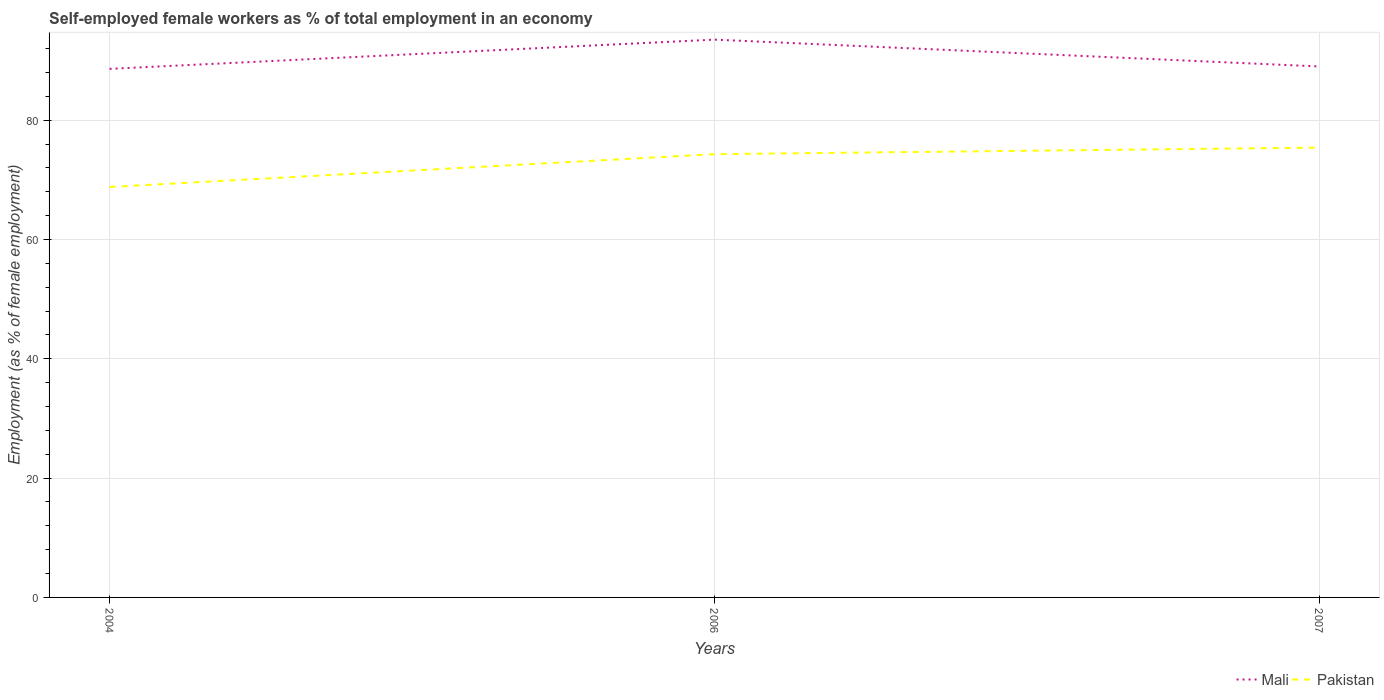How many different coloured lines are there?
Keep it short and to the point. 2. Does the line corresponding to Pakistan intersect with the line corresponding to Mali?
Make the answer very short. No. Across all years, what is the maximum percentage of self-employed female workers in Pakistan?
Your answer should be compact. 68.8. What is the total percentage of self-employed female workers in Pakistan in the graph?
Your answer should be very brief. -6.6. What is the difference between the highest and the second highest percentage of self-employed female workers in Mali?
Provide a short and direct response. 4.9. What is the difference between the highest and the lowest percentage of self-employed female workers in Pakistan?
Your answer should be compact. 2. Is the percentage of self-employed female workers in Mali strictly greater than the percentage of self-employed female workers in Pakistan over the years?
Keep it short and to the point. No. How many lines are there?
Your answer should be compact. 2. Are the values on the major ticks of Y-axis written in scientific E-notation?
Keep it short and to the point. No. Does the graph contain any zero values?
Make the answer very short. No. What is the title of the graph?
Your answer should be compact. Self-employed female workers as % of total employment in an economy. What is the label or title of the Y-axis?
Give a very brief answer. Employment (as % of female employment). What is the Employment (as % of female employment) of Mali in 2004?
Offer a terse response. 88.6. What is the Employment (as % of female employment) of Pakistan in 2004?
Your response must be concise. 68.8. What is the Employment (as % of female employment) in Mali in 2006?
Your answer should be very brief. 93.5. What is the Employment (as % of female employment) in Pakistan in 2006?
Keep it short and to the point. 74.3. What is the Employment (as % of female employment) of Mali in 2007?
Provide a short and direct response. 89. What is the Employment (as % of female employment) in Pakistan in 2007?
Your answer should be very brief. 75.4. Across all years, what is the maximum Employment (as % of female employment) in Mali?
Ensure brevity in your answer.  93.5. Across all years, what is the maximum Employment (as % of female employment) of Pakistan?
Your response must be concise. 75.4. Across all years, what is the minimum Employment (as % of female employment) in Mali?
Ensure brevity in your answer.  88.6. Across all years, what is the minimum Employment (as % of female employment) of Pakistan?
Your answer should be compact. 68.8. What is the total Employment (as % of female employment) in Mali in the graph?
Your answer should be very brief. 271.1. What is the total Employment (as % of female employment) in Pakistan in the graph?
Provide a succinct answer. 218.5. What is the difference between the Employment (as % of female employment) of Mali in 2004 and that in 2006?
Provide a short and direct response. -4.9. What is the difference between the Employment (as % of female employment) in Pakistan in 2004 and that in 2006?
Provide a short and direct response. -5.5. What is the difference between the Employment (as % of female employment) in Pakistan in 2004 and that in 2007?
Your answer should be very brief. -6.6. What is the difference between the Employment (as % of female employment) of Pakistan in 2006 and that in 2007?
Provide a succinct answer. -1.1. What is the average Employment (as % of female employment) of Mali per year?
Give a very brief answer. 90.37. What is the average Employment (as % of female employment) in Pakistan per year?
Make the answer very short. 72.83. In the year 2004, what is the difference between the Employment (as % of female employment) in Mali and Employment (as % of female employment) in Pakistan?
Offer a very short reply. 19.8. In the year 2006, what is the difference between the Employment (as % of female employment) in Mali and Employment (as % of female employment) in Pakistan?
Give a very brief answer. 19.2. What is the ratio of the Employment (as % of female employment) in Mali in 2004 to that in 2006?
Give a very brief answer. 0.95. What is the ratio of the Employment (as % of female employment) of Pakistan in 2004 to that in 2006?
Ensure brevity in your answer.  0.93. What is the ratio of the Employment (as % of female employment) in Pakistan in 2004 to that in 2007?
Provide a short and direct response. 0.91. What is the ratio of the Employment (as % of female employment) of Mali in 2006 to that in 2007?
Your answer should be compact. 1.05. What is the ratio of the Employment (as % of female employment) of Pakistan in 2006 to that in 2007?
Give a very brief answer. 0.99. What is the difference between the highest and the second highest Employment (as % of female employment) in Mali?
Offer a very short reply. 4.5. What is the difference between the highest and the lowest Employment (as % of female employment) in Mali?
Give a very brief answer. 4.9. What is the difference between the highest and the lowest Employment (as % of female employment) of Pakistan?
Provide a succinct answer. 6.6. 